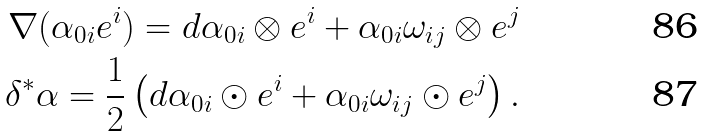Convert formula to latex. <formula><loc_0><loc_0><loc_500><loc_500>\nabla ( \alpha _ { 0 i } e ^ { i } ) = d \alpha _ { 0 i } \otimes e ^ { i } + \alpha _ { 0 i } \omega _ { i j } \otimes e ^ { j } \\ \delta ^ { \ast } \alpha = \frac { 1 } { 2 } \left ( d \alpha _ { 0 i } \odot e ^ { i } + \alpha _ { 0 i } \omega _ { i j } \odot e ^ { j } \right ) .</formula> 